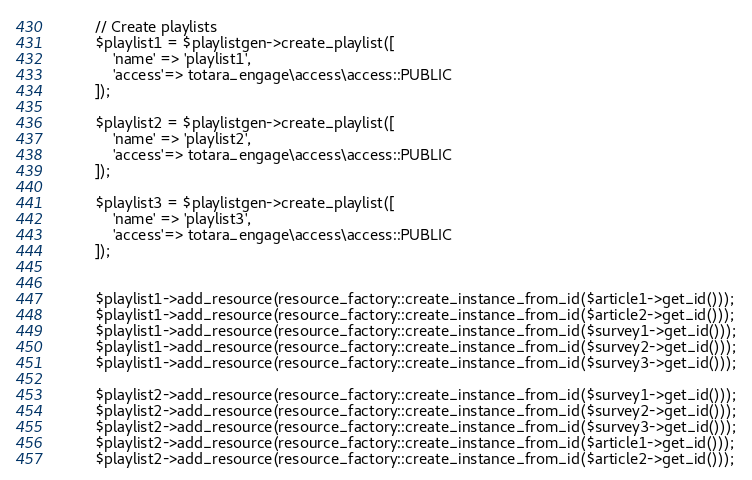Convert code to text. <code><loc_0><loc_0><loc_500><loc_500><_PHP_>
        // Create playlists
        $playlist1 = $playlistgen->create_playlist([
            'name' => 'playlist1',
            'access'=> totara_engage\access\access::PUBLIC
        ]);

        $playlist2 = $playlistgen->create_playlist([
            'name' => 'playlist2',
            'access'=> totara_engage\access\access::PUBLIC
        ]);

        $playlist3 = $playlistgen->create_playlist([
            'name' => 'playlist3',
            'access'=> totara_engage\access\access::PUBLIC
        ]);


        $playlist1->add_resource(resource_factory::create_instance_from_id($article1->get_id()));
        $playlist1->add_resource(resource_factory::create_instance_from_id($article2->get_id()));
        $playlist1->add_resource(resource_factory::create_instance_from_id($survey1->get_id()));
        $playlist1->add_resource(resource_factory::create_instance_from_id($survey2->get_id()));
        $playlist1->add_resource(resource_factory::create_instance_from_id($survey3->get_id()));

        $playlist2->add_resource(resource_factory::create_instance_from_id($survey1->get_id()));
        $playlist2->add_resource(resource_factory::create_instance_from_id($survey2->get_id()));
        $playlist2->add_resource(resource_factory::create_instance_from_id($survey3->get_id()));
        $playlist2->add_resource(resource_factory::create_instance_from_id($article1->get_id()));
        $playlist2->add_resource(resource_factory::create_instance_from_id($article2->get_id()));
</code> 